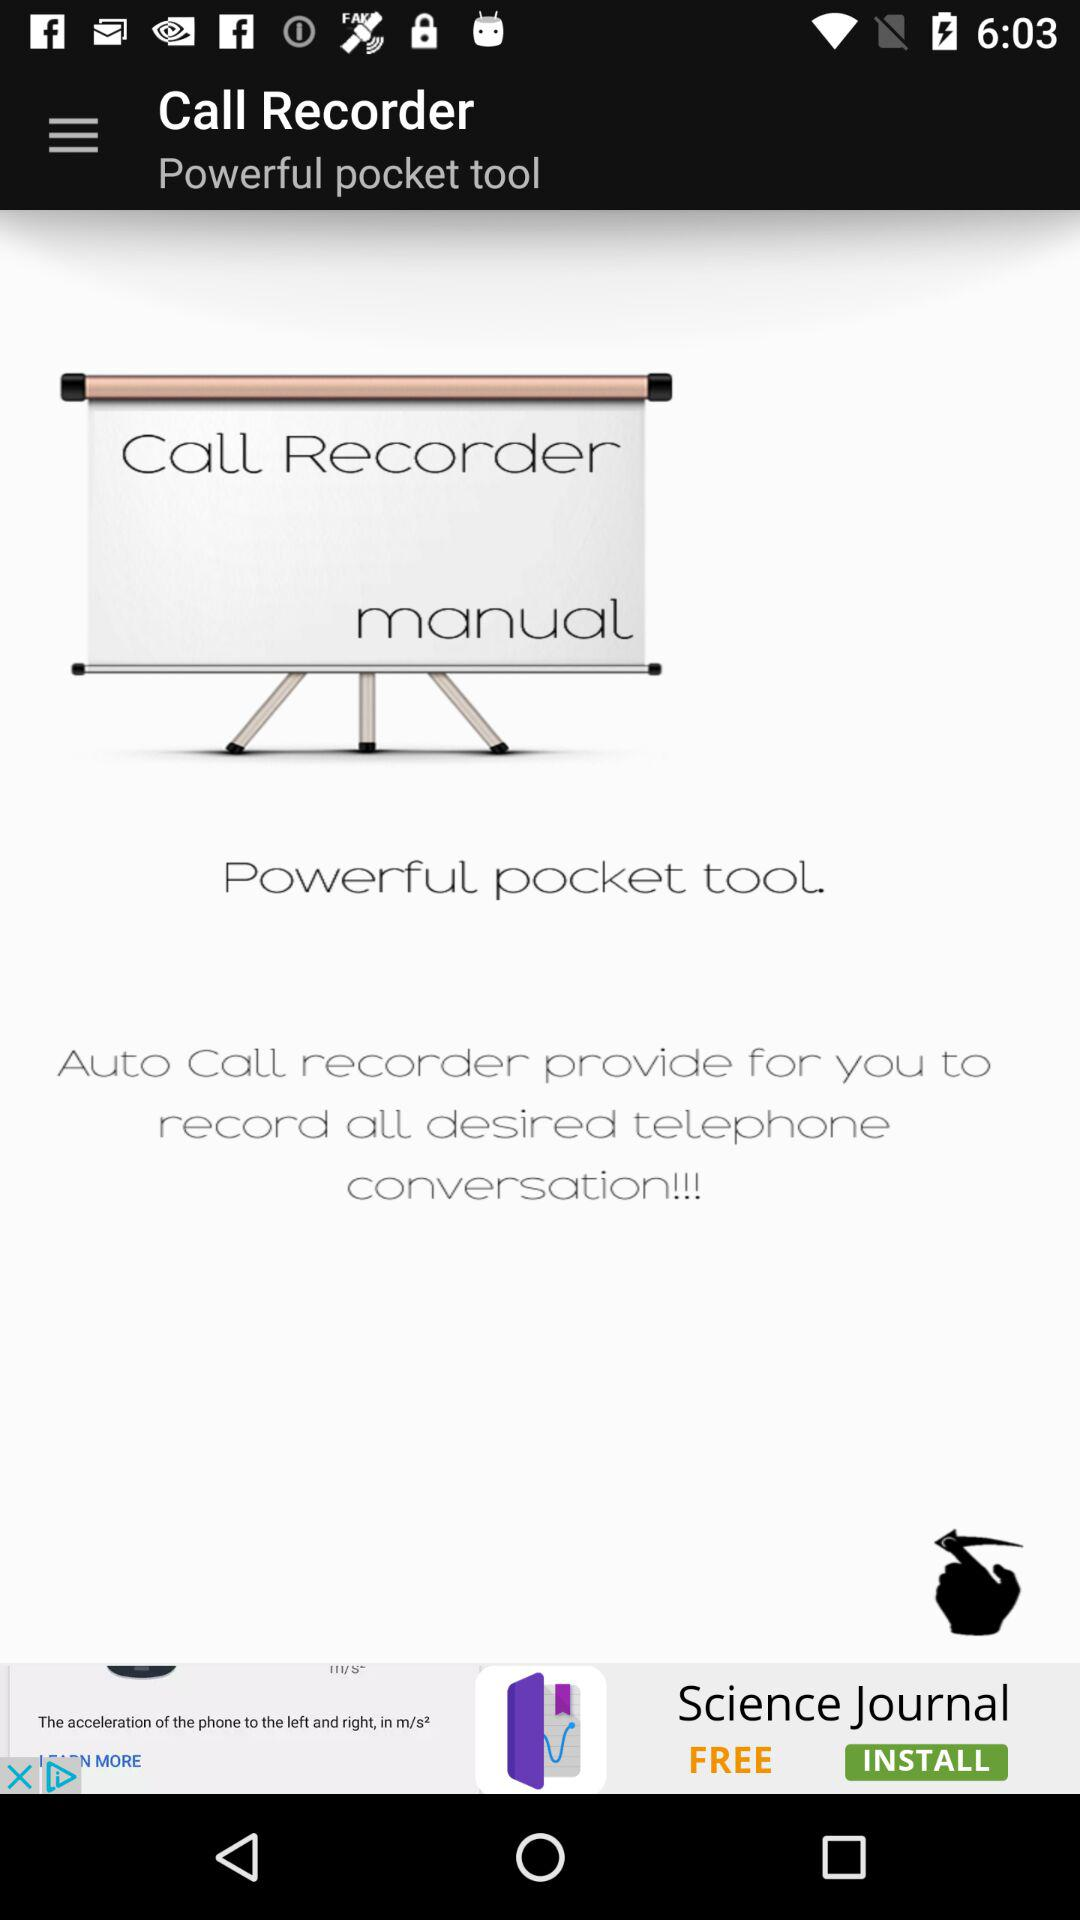What is the application name? The application name is "Auto Call recorder". 